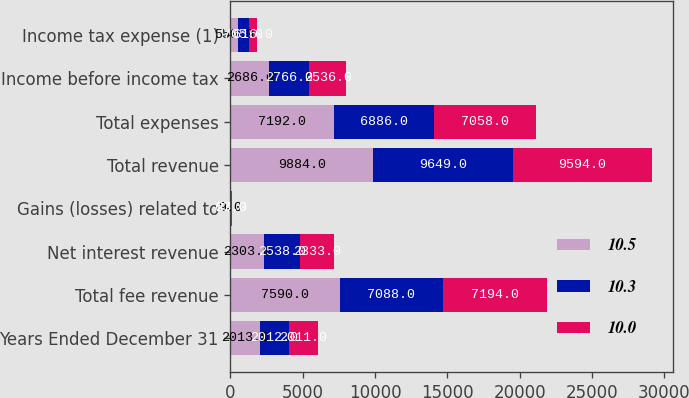<chart> <loc_0><loc_0><loc_500><loc_500><stacked_bar_chart><ecel><fcel>Years Ended December 31<fcel>Total fee revenue<fcel>Net interest revenue<fcel>Gains (losses) related to<fcel>Total revenue<fcel>Total expenses<fcel>Income before income tax<fcel>Income tax expense (1)<nl><fcel>10.5<fcel>2013<fcel>7590<fcel>2303<fcel>9<fcel>9884<fcel>7192<fcel>2686<fcel>550<nl><fcel>10.3<fcel>2012<fcel>7088<fcel>2538<fcel>23<fcel>9649<fcel>6886<fcel>2766<fcel>705<nl><fcel>10<fcel>2011<fcel>7194<fcel>2333<fcel>67<fcel>9594<fcel>7058<fcel>2536<fcel>616<nl></chart> 